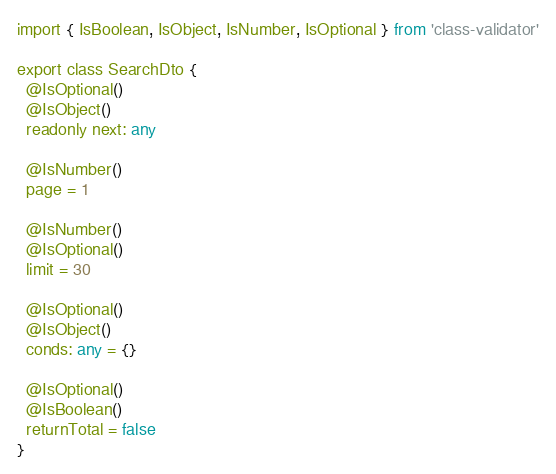<code> <loc_0><loc_0><loc_500><loc_500><_TypeScript_>import { IsBoolean, IsObject, IsNumber, IsOptional } from 'class-validator'

export class SearchDto {
  @IsOptional()
  @IsObject()
  readonly next: any

  @IsNumber()
  page = 1

  @IsNumber()
  @IsOptional()
  limit = 30

  @IsOptional()
  @IsObject()
  conds: any = {}

  @IsOptional()
  @IsBoolean()
  returnTotal = false
}
</code> 